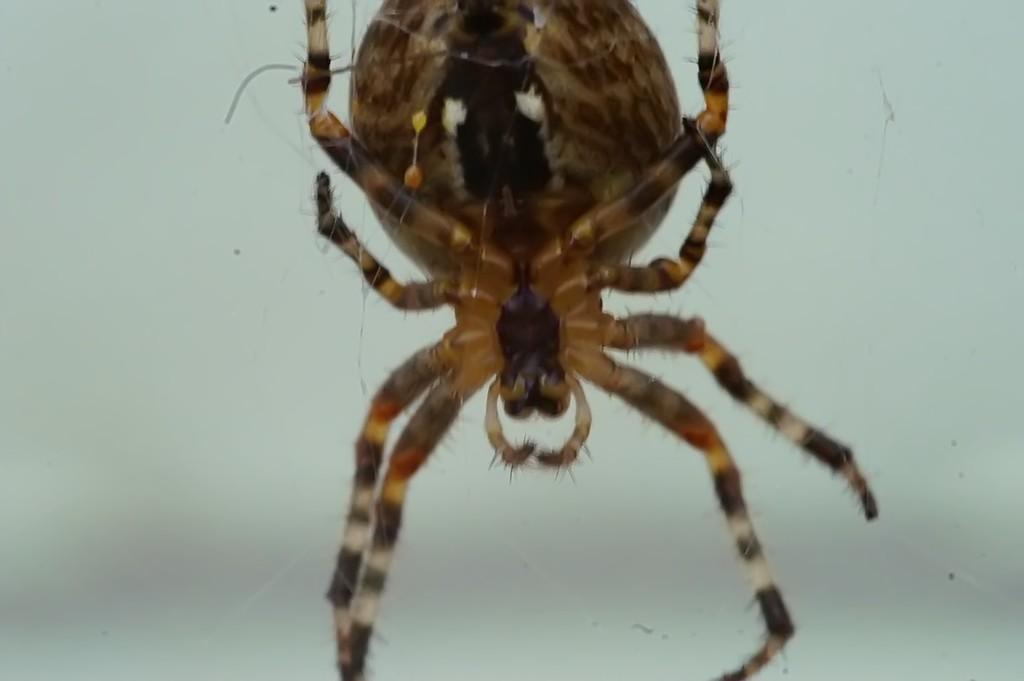In one or two sentences, can you explain what this image depicts? In this image we can see one big spider. 